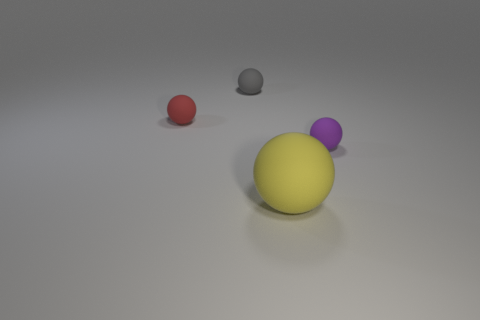The rubber ball in front of the tiny object right of the ball behind the tiny red object is what color?
Make the answer very short. Yellow. Is the shape of the matte object that is right of the large sphere the same as the tiny object that is behind the red sphere?
Your answer should be very brief. Yes. What number of big blue matte blocks are there?
Make the answer very short. 0. Is the material of the tiny object to the right of the yellow ball the same as the tiny ball that is to the left of the gray matte sphere?
Your answer should be very brief. Yes. There is a object to the left of the ball that is behind the red matte object; what is its size?
Your response must be concise. Small. There is a thing behind the tiny red object; what is its material?
Your answer should be compact. Rubber. What number of things are matte objects that are behind the purple matte ball or rubber objects that are behind the red sphere?
Offer a terse response. 2. What material is the purple object that is the same shape as the tiny red matte thing?
Ensure brevity in your answer.  Rubber. Does the sphere that is behind the tiny red matte ball have the same color as the rubber object to the left of the gray sphere?
Keep it short and to the point. No. Is there a red cylinder that has the same size as the red rubber object?
Give a very brief answer. No. 